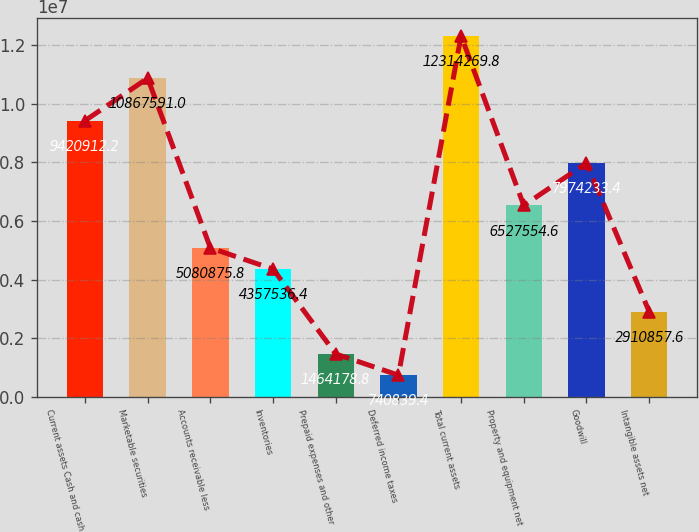Convert chart. <chart><loc_0><loc_0><loc_500><loc_500><bar_chart><fcel>Current assets Cash and cash<fcel>Marketable securities<fcel>Accounts receivable less<fcel>Inventories<fcel>Prepaid expenses and other<fcel>Deferred income taxes<fcel>Total current assets<fcel>Property and equipment net<fcel>Goodwill<fcel>Intangible assets net<nl><fcel>9.42091e+06<fcel>1.08676e+07<fcel>5.08088e+06<fcel>4.35754e+06<fcel>1.46418e+06<fcel>740839<fcel>1.23143e+07<fcel>6.52755e+06<fcel>7.97423e+06<fcel>2.91086e+06<nl></chart> 